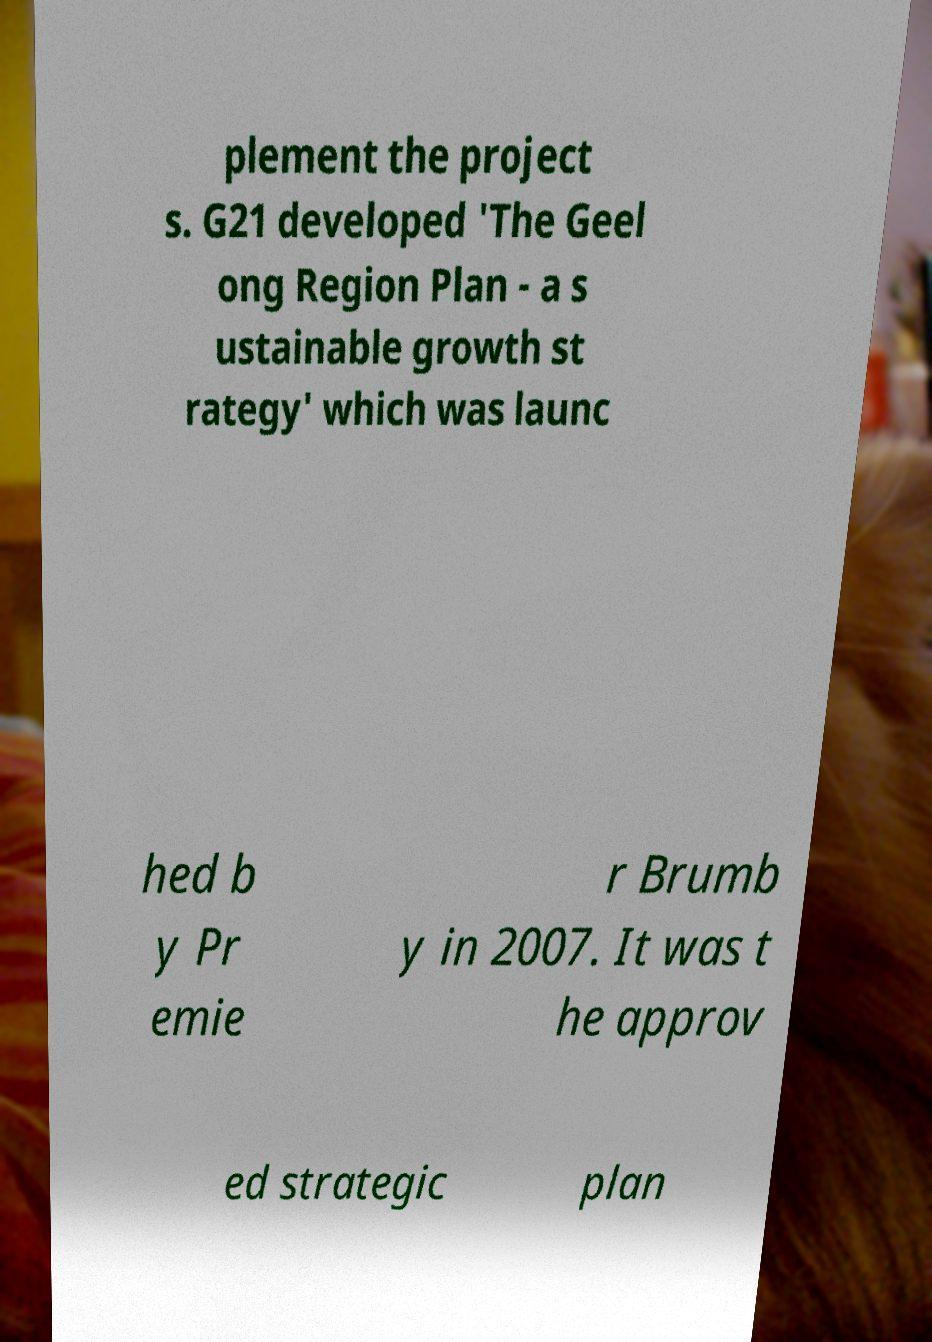Can you read and provide the text displayed in the image?This photo seems to have some interesting text. Can you extract and type it out for me? plement the project s. G21 developed 'The Geel ong Region Plan - a s ustainable growth st rategy' which was launc hed b y Pr emie r Brumb y in 2007. It was t he approv ed strategic plan 